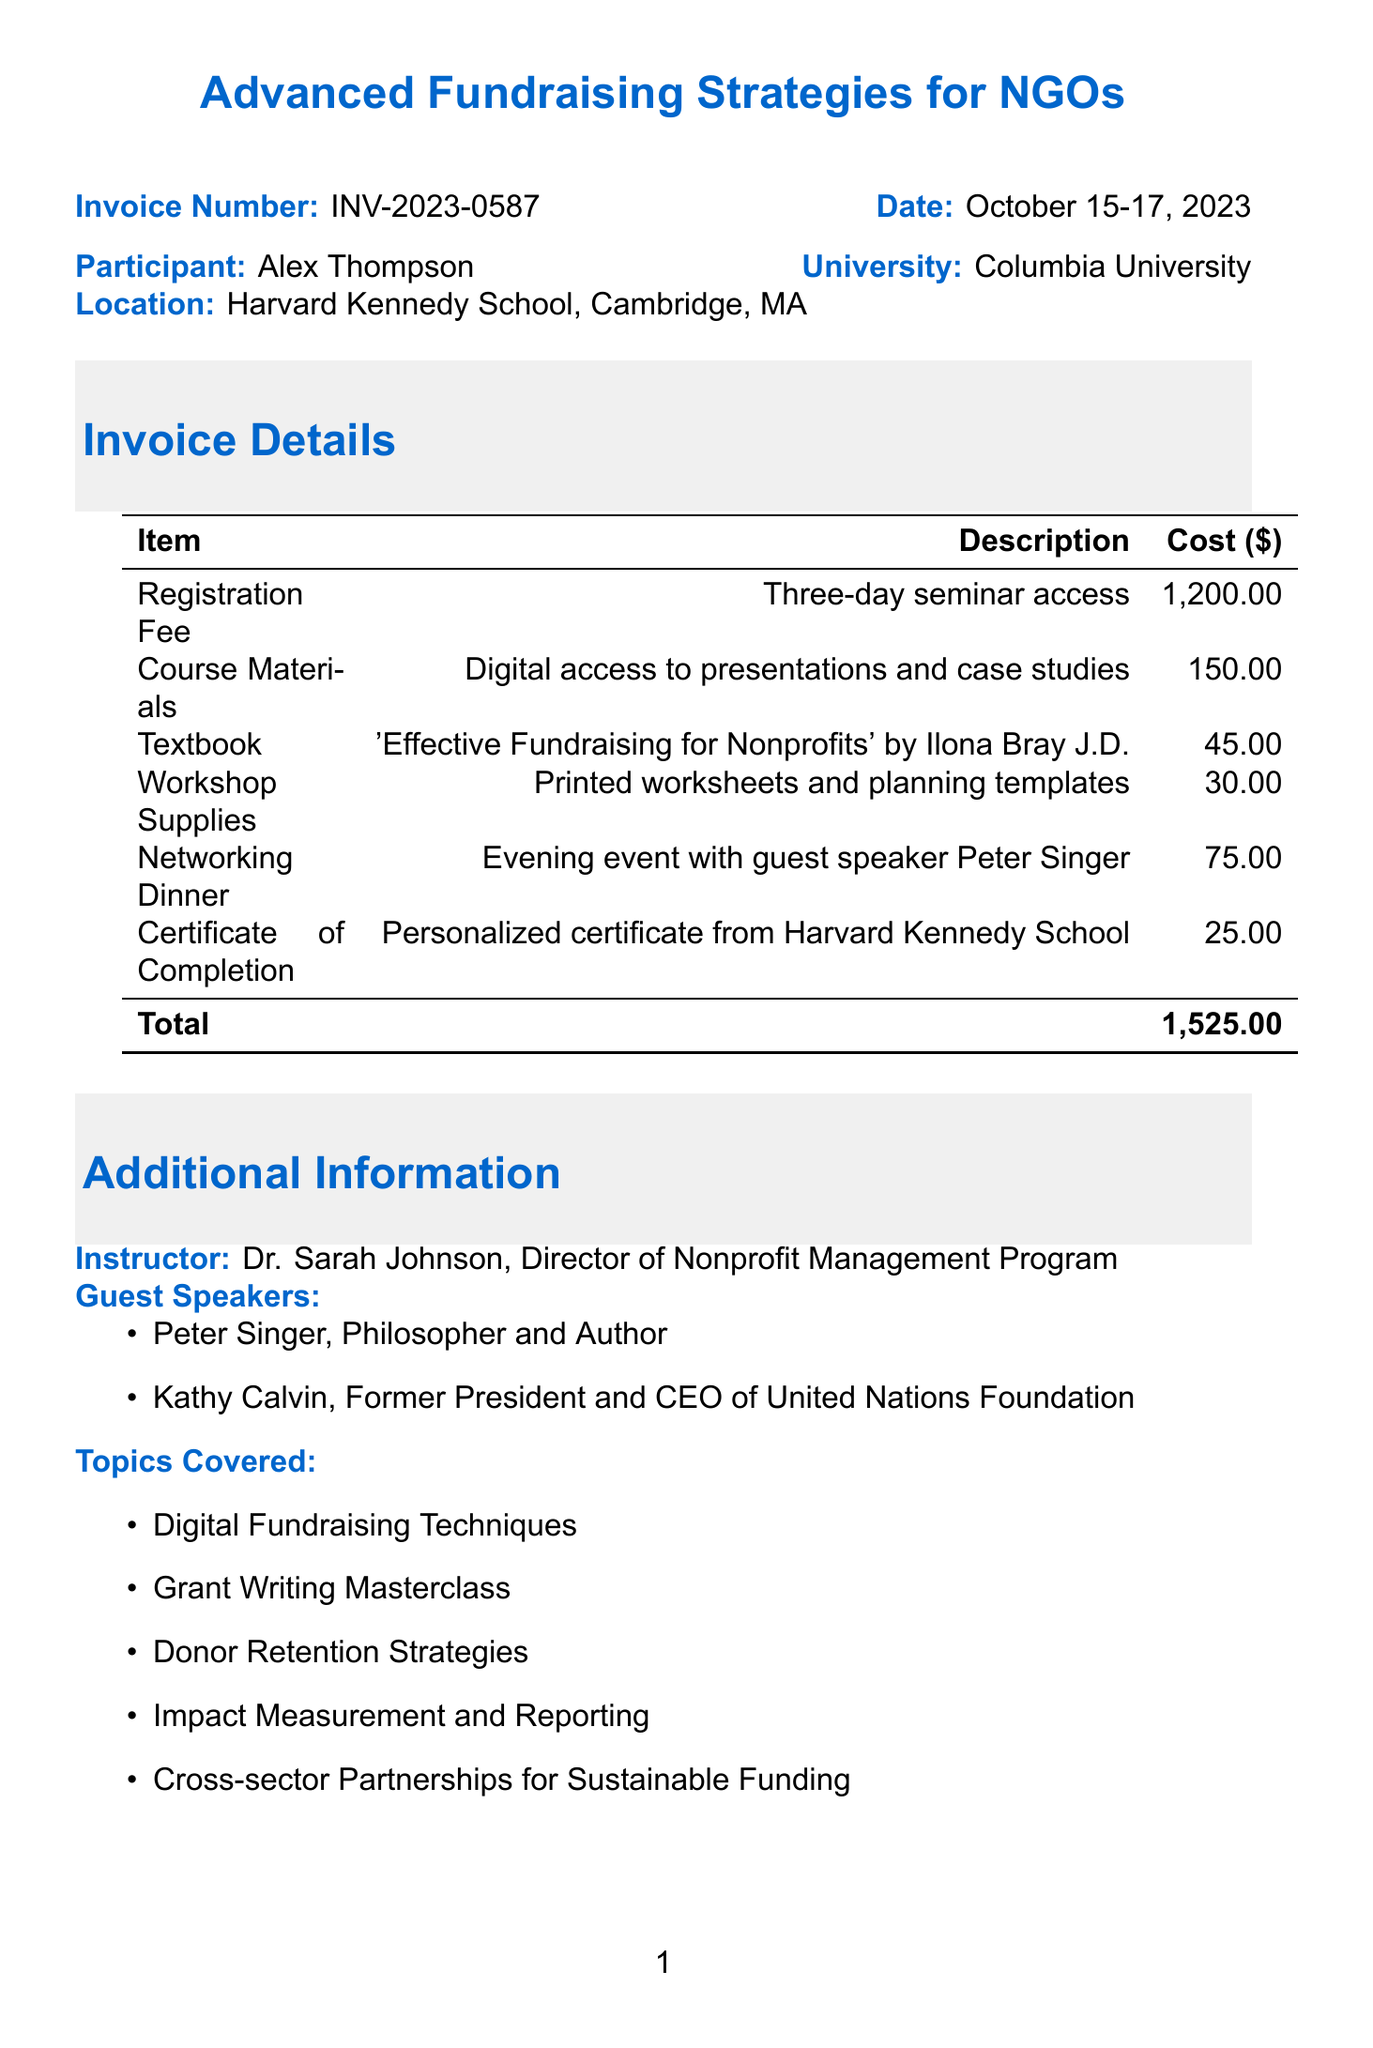What is the invoice number? The invoice number is clearly stated in the document as a unique identifier for the invoice.
Answer: INV-2023-0587 What are the payment methods listed? The document explicitly lists the accepted methods of payment for the invoice.
Answer: Credit Card, Bank Transfer, University Purchase Order What is the date of the seminar? The document specifies the dates during which the seminar will take place.
Answer: October 15-17, 2023 Who is the instructor for the seminar? The document mentions the instructor's name and title, providing important information about the seminar's leadership.
Answer: Dr. Sarah Johnson What is the cost of the textbook? The invoice provides a breakdown of costs for course materials, including the price of the textbook.
Answer: 45.00 What is the total amount due? The total amount due at the end of the invoice sums up all costs associated with the seminar.
Answer: 1,525.00 Which guest speaker is associated with the networking dinner? The document details the guest speaker featured at the specific evening event.
Answer: Peter Singer What are the topics covered in the seminar? The document lists several specific topics that will be addressed during the seminar, indicating the focus of the program.
Answer: Digital Fundraising Techniques, Grant Writing Masterclass, Donor Retention Strategies, Impact Measurement and Reporting, Cross-sector Partnerships for Sustainable Funding When is the payment due date? The document states the deadline for payment, an important detail for participants to note.
Answer: September 30, 2023 